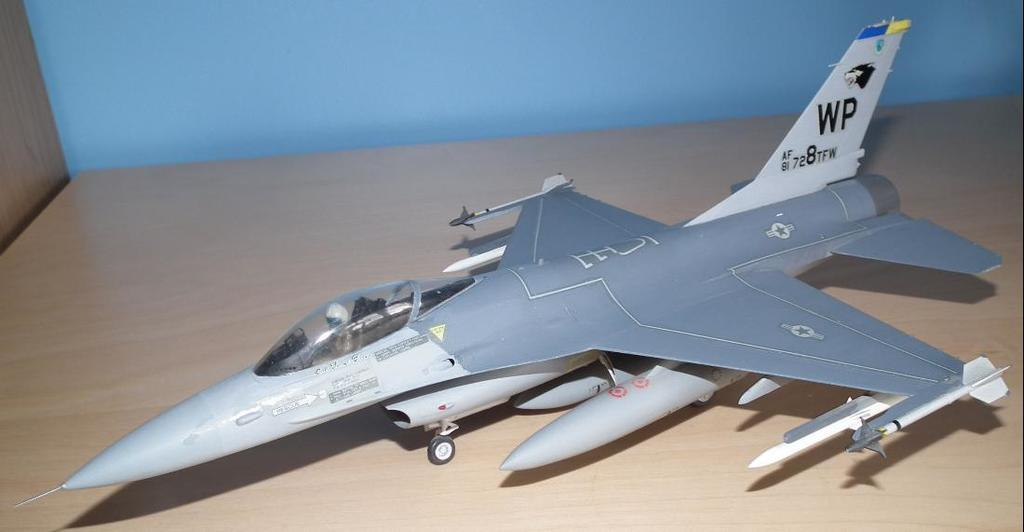<image>
Relay a brief, clear account of the picture shown. A model of a silver jet is on a table with the letters WP on its tail. 